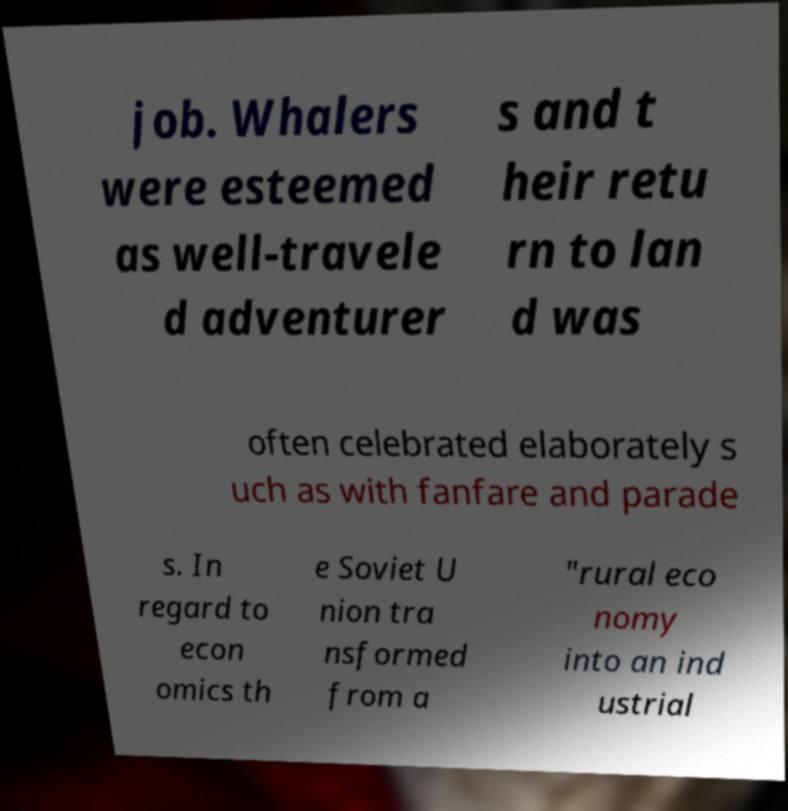Please identify and transcribe the text found in this image. job. Whalers were esteemed as well-travele d adventurer s and t heir retu rn to lan d was often celebrated elaborately s uch as with fanfare and parade s. In regard to econ omics th e Soviet U nion tra nsformed from a "rural eco nomy into an ind ustrial 